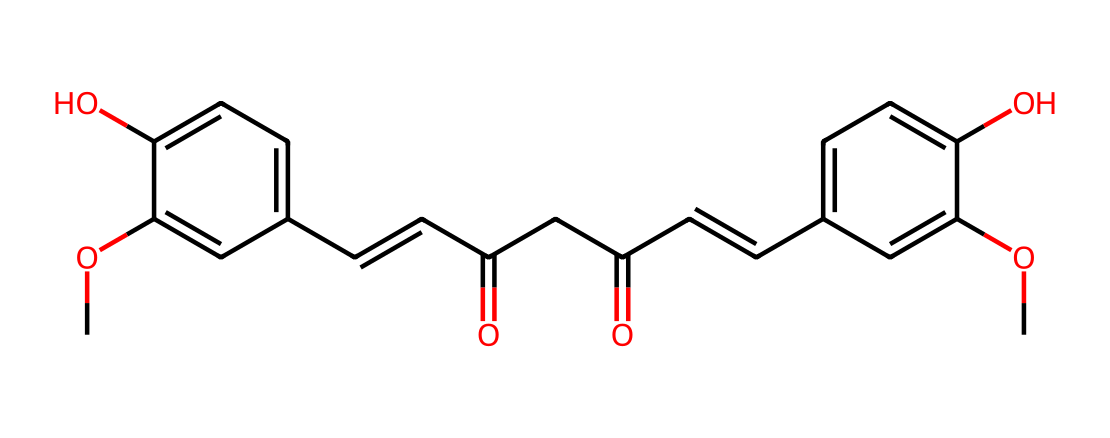how many hydroxyl groups are present in this molecule? By examining the structure, we can identify hydroxyl groups (–OH) present in the chemical. In this particular structure, we find two –OH groups attached to the aromatic rings.
Answer: two what is the molecular formula of curcumin? To find the molecular formula, we need to count the number of each type of atom in the structure presented by the SMILES code. The structure contains 21 carbon atoms, 20 hydrogen atoms, and 6 oxygen atoms, leading to the formula C21H20O6.
Answer: C21H20O6 how many double bonds are in this molecule? Looking at the chemical structure, we can identify double bonds (C=C) by observing the connections between carbon atoms. There are two places in the structure where double bonds exist.
Answer: two what type of functional groups are present in curcumin? We identify the functional groups by analyzing the chemical structure. The presence of hydroxyl groups (–OH) and carbonyl groups (C=O) indicates that this molecule contains phenolic and diketone functional groups.
Answer: phenolic and diketone what is the significance of hydroxyl groups in phenols? Hydroxyl groups in phenolic compounds enhance their reactivity and solubility in water, affecting their biological activity, such as antioxidant properties. This is crucial for many applications, including those in traditional medicine.
Answer: reactivity and solubility 